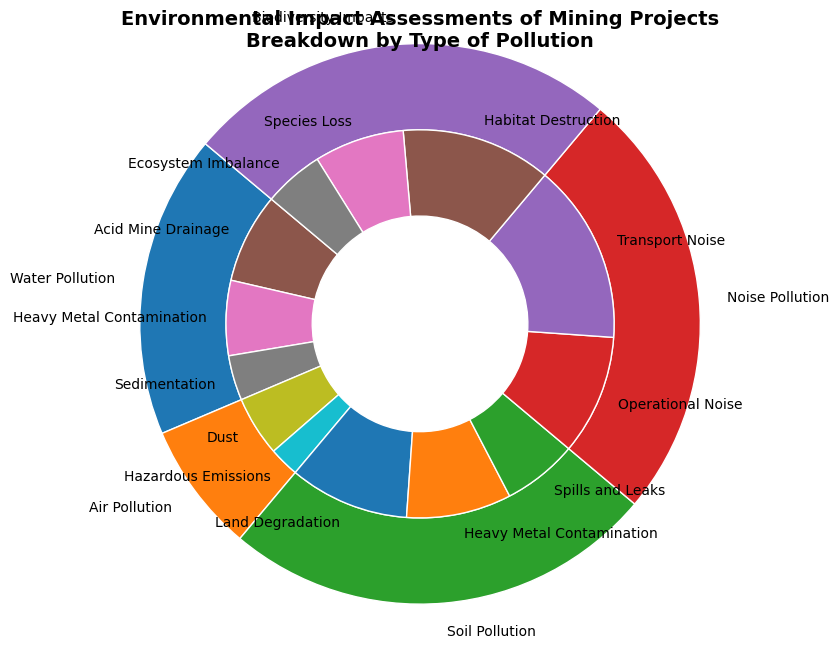What percentage of the total impact is due to Water Pollution? To determine the percentage impact of Water Pollution, locate the segment labeled "Water Pollution". The total percentage for Water Pollution is the sum of its sub-types: Acid Mine Drainage (30%), Heavy Metal Contamination (25%), and Sedimentation (15%). Adding these values: 30 + 25 + 15 = 70%.
Answer: 70% Which pollution type has the highest total impact? Compare the outer ring segments labeled by pollution types. Water Pollution has a total impact of 70%, Air Pollution 30%, Soil Pollution 100%, Noise Pollution 100%, and Biodiversity Impacts 100%. The highest is Soil Pollution, Noise Pollution, and Biodiversity Impacts, each with 100%.
Answer: Soil Pollution, Noise Pollution, Biodiversity Impacts What is the combined impact of Acid Mine Drainage from Water Pollution and Dust from Air Pollution? First, find the segment for "Acid Mine Drainage" under Water Pollution (30%) and "Dust" under Air Pollution (20%). Add their percentages: 30% + 20% = 50%.
Answer: 50% Which sub-type under Biodiversity Impacts has the smallest percentage? Look at the sub-types under the Biodiversity Impacts segment. Habitat Destruction is 50%, Species Loss is 30%, and Ecosystem Imbalance is 20%. The smallest percentage is Ecosystem Imbalance.
Answer: Ecosystem Imbalance What is the difference between Land Degradation and Heavy Metal Contamination within Soil Pollution? Find Land Degradation (40%) and Heavy Metal Contamination (35%) under Soil Pollution. Subtract the smaller from the larger: 40% - 35% = 5%.
Answer: 5% What is the sum of the impacts of all sub-types under Noise Pollution? Locate Operational Noise (40%) and Transport Noise (60%) under Noise Pollution. Add their percentages: 40% + 60% = 100%.
Answer: 100% Is the impact of Species Loss under Biodiversity Impacts greater than the impact of Dust under Air Pollution? Compare Species Loss (30%) under Biodiversity Impacts with Dust (20%) under Air Pollution. 30% is greater than 20%.
Answer: Yes Which type of pollution has the greater impact: Water Pollution or Air Pollution? Compare the total impact percentages for Water Pollution (70%) and Air Pollution (30%). Since 70% > 30%, Water Pollution has a greater impact.
Answer: Water Pollution What percentage of the total impact does Heavy Metal Contamination contribute across all types of pollution combined? Summarize Heavy Metal Contamination across Water Pollution (25%) and Soil Pollution (35%). Add: 25% + 35% = 60%.
Answer: 60% Which sub-type under Soil Pollution contributes more to the total impact: Heavy Metal Contamination or Spills and Leaks? Compare Heavy Metal Contamination (35%) and Spills and Leaks (25%) under Soil Pollution. 35% is more than 25%.
Answer: Heavy Metal Contamination 